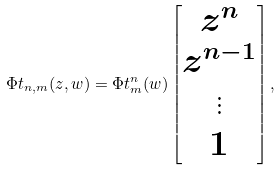Convert formula to latex. <formula><loc_0><loc_0><loc_500><loc_500>\Phi t _ { n , m } ( z , w ) = \Phi t ^ { n } _ { m } ( w ) \left [ \begin{matrix} z ^ { n } \\ z ^ { n - 1 } \\ \vdots \\ 1 \end{matrix} \right ] ,</formula> 